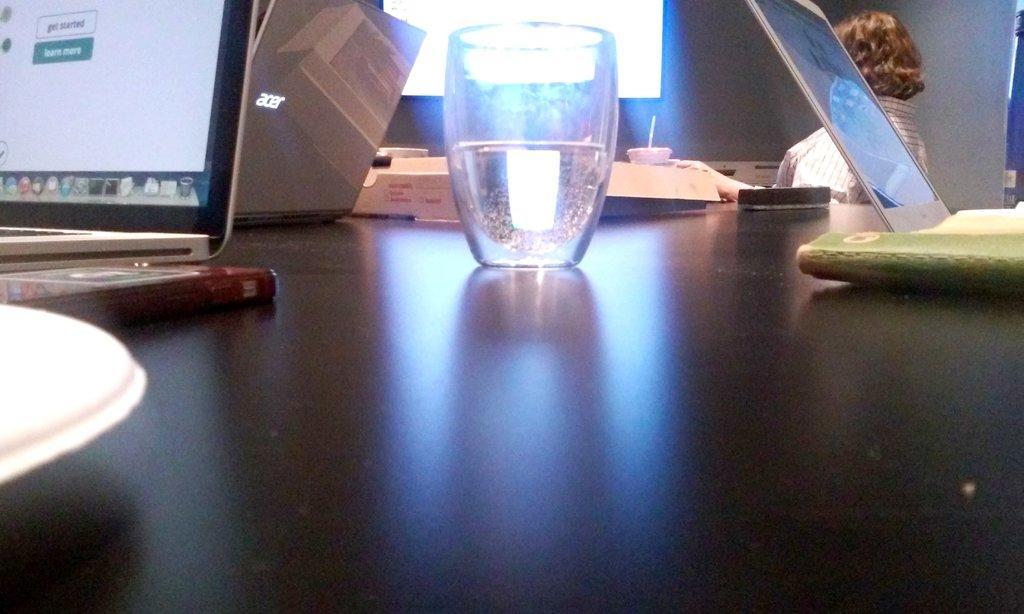How would you summarize this image in a sentence or two? This picture is of inside. In the foreground we can see there is a table on the top of which a book, a glass of water, box and laptops are placed, behind the table there is a woman wearing shirt seems to be sitting. In the background we can see a window and a pillar. 